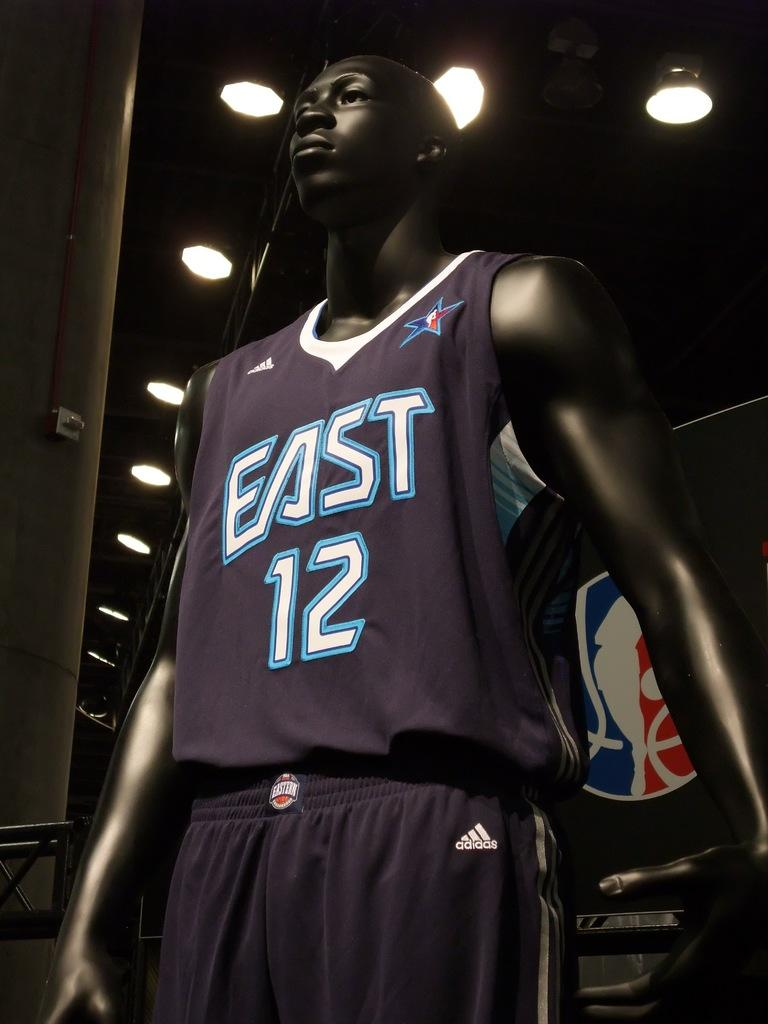What is on display in the image? There is a dress on a mannequin in the image. What type of lighting is present in the image? There are ceiling lights visible in the image. Where are the ceiling lights located in relation to the roof? The ceiling lights are near a roof. What is the name of the baby in the image? There is no baby present in the image. 